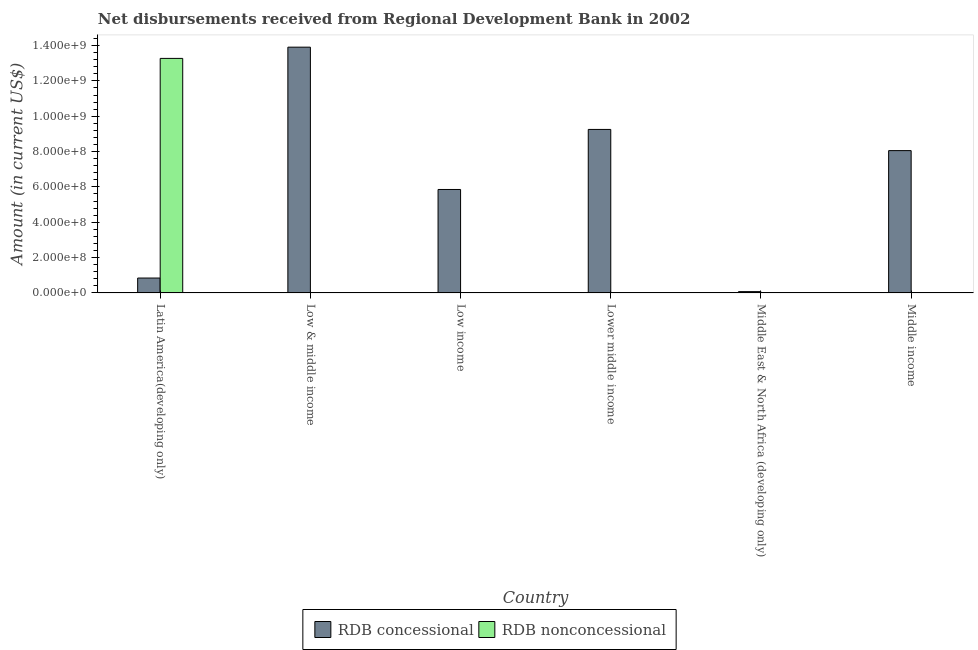Are the number of bars per tick equal to the number of legend labels?
Your response must be concise. No. Are the number of bars on each tick of the X-axis equal?
Offer a terse response. No. How many bars are there on the 5th tick from the left?
Give a very brief answer. 1. How many bars are there on the 3rd tick from the right?
Provide a succinct answer. 1. What is the label of the 3rd group of bars from the left?
Your answer should be compact. Low income. In how many cases, is the number of bars for a given country not equal to the number of legend labels?
Give a very brief answer. 5. What is the net non concessional disbursements from rdb in Latin America(developing only)?
Provide a succinct answer. 1.33e+09. Across all countries, what is the maximum net non concessional disbursements from rdb?
Make the answer very short. 1.33e+09. Across all countries, what is the minimum net concessional disbursements from rdb?
Your answer should be compact. 7.38e+06. In which country was the net non concessional disbursements from rdb maximum?
Provide a short and direct response. Latin America(developing only). What is the total net concessional disbursements from rdb in the graph?
Offer a terse response. 3.80e+09. What is the difference between the net concessional disbursements from rdb in Latin America(developing only) and that in Middle East & North Africa (developing only)?
Ensure brevity in your answer.  7.69e+07. What is the difference between the net concessional disbursements from rdb in Middle income and the net non concessional disbursements from rdb in Low & middle income?
Provide a short and direct response. 8.05e+08. What is the average net concessional disbursements from rdb per country?
Provide a succinct answer. 6.33e+08. What is the difference between the net non concessional disbursements from rdb and net concessional disbursements from rdb in Latin America(developing only)?
Your answer should be compact. 1.24e+09. In how many countries, is the net non concessional disbursements from rdb greater than 440000000 US$?
Provide a succinct answer. 1. What is the ratio of the net concessional disbursements from rdb in Latin America(developing only) to that in Low & middle income?
Give a very brief answer. 0.06. What is the difference between the highest and the second highest net concessional disbursements from rdb?
Ensure brevity in your answer.  4.66e+08. What is the difference between the highest and the lowest net non concessional disbursements from rdb?
Offer a very short reply. 1.33e+09. How many bars are there?
Your answer should be very brief. 7. Are all the bars in the graph horizontal?
Provide a succinct answer. No. What is the difference between two consecutive major ticks on the Y-axis?
Keep it short and to the point. 2.00e+08. Are the values on the major ticks of Y-axis written in scientific E-notation?
Your answer should be compact. Yes. Does the graph contain grids?
Keep it short and to the point. No. How many legend labels are there?
Ensure brevity in your answer.  2. How are the legend labels stacked?
Offer a terse response. Horizontal. What is the title of the graph?
Keep it short and to the point. Net disbursements received from Regional Development Bank in 2002. Does "Goods" appear as one of the legend labels in the graph?
Keep it short and to the point. No. What is the Amount (in current US$) of RDB concessional in Latin America(developing only)?
Provide a succinct answer. 8.43e+07. What is the Amount (in current US$) in RDB nonconcessional in Latin America(developing only)?
Your answer should be compact. 1.33e+09. What is the Amount (in current US$) in RDB concessional in Low & middle income?
Make the answer very short. 1.39e+09. What is the Amount (in current US$) in RDB concessional in Low income?
Your answer should be very brief. 5.86e+08. What is the Amount (in current US$) of RDB concessional in Lower middle income?
Ensure brevity in your answer.  9.25e+08. What is the Amount (in current US$) of RDB concessional in Middle East & North Africa (developing only)?
Offer a very short reply. 7.38e+06. What is the Amount (in current US$) in RDB concessional in Middle income?
Your answer should be compact. 8.05e+08. Across all countries, what is the maximum Amount (in current US$) of RDB concessional?
Your answer should be compact. 1.39e+09. Across all countries, what is the maximum Amount (in current US$) of RDB nonconcessional?
Ensure brevity in your answer.  1.33e+09. Across all countries, what is the minimum Amount (in current US$) in RDB concessional?
Give a very brief answer. 7.38e+06. What is the total Amount (in current US$) of RDB concessional in the graph?
Your answer should be very brief. 3.80e+09. What is the total Amount (in current US$) of RDB nonconcessional in the graph?
Provide a succinct answer. 1.33e+09. What is the difference between the Amount (in current US$) in RDB concessional in Latin America(developing only) and that in Low & middle income?
Your response must be concise. -1.31e+09. What is the difference between the Amount (in current US$) in RDB concessional in Latin America(developing only) and that in Low income?
Ensure brevity in your answer.  -5.01e+08. What is the difference between the Amount (in current US$) of RDB concessional in Latin America(developing only) and that in Lower middle income?
Your answer should be compact. -8.41e+08. What is the difference between the Amount (in current US$) of RDB concessional in Latin America(developing only) and that in Middle East & North Africa (developing only)?
Your answer should be very brief. 7.69e+07. What is the difference between the Amount (in current US$) of RDB concessional in Latin America(developing only) and that in Middle income?
Your answer should be compact. -7.21e+08. What is the difference between the Amount (in current US$) of RDB concessional in Low & middle income and that in Low income?
Your response must be concise. 8.05e+08. What is the difference between the Amount (in current US$) in RDB concessional in Low & middle income and that in Lower middle income?
Offer a terse response. 4.66e+08. What is the difference between the Amount (in current US$) in RDB concessional in Low & middle income and that in Middle East & North Africa (developing only)?
Provide a short and direct response. 1.38e+09. What is the difference between the Amount (in current US$) of RDB concessional in Low & middle income and that in Middle income?
Make the answer very short. 5.86e+08. What is the difference between the Amount (in current US$) of RDB concessional in Low income and that in Lower middle income?
Ensure brevity in your answer.  -3.40e+08. What is the difference between the Amount (in current US$) in RDB concessional in Low income and that in Middle East & North Africa (developing only)?
Make the answer very short. 5.78e+08. What is the difference between the Amount (in current US$) of RDB concessional in Low income and that in Middle income?
Ensure brevity in your answer.  -2.20e+08. What is the difference between the Amount (in current US$) in RDB concessional in Lower middle income and that in Middle East & North Africa (developing only)?
Your answer should be compact. 9.18e+08. What is the difference between the Amount (in current US$) of RDB concessional in Lower middle income and that in Middle income?
Your response must be concise. 1.20e+08. What is the difference between the Amount (in current US$) in RDB concessional in Middle East & North Africa (developing only) and that in Middle income?
Provide a short and direct response. -7.98e+08. What is the average Amount (in current US$) in RDB concessional per country?
Your response must be concise. 6.33e+08. What is the average Amount (in current US$) of RDB nonconcessional per country?
Your answer should be compact. 2.21e+08. What is the difference between the Amount (in current US$) in RDB concessional and Amount (in current US$) in RDB nonconcessional in Latin America(developing only)?
Your answer should be very brief. -1.24e+09. What is the ratio of the Amount (in current US$) in RDB concessional in Latin America(developing only) to that in Low & middle income?
Provide a succinct answer. 0.06. What is the ratio of the Amount (in current US$) in RDB concessional in Latin America(developing only) to that in Low income?
Provide a succinct answer. 0.14. What is the ratio of the Amount (in current US$) in RDB concessional in Latin America(developing only) to that in Lower middle income?
Your response must be concise. 0.09. What is the ratio of the Amount (in current US$) in RDB concessional in Latin America(developing only) to that in Middle East & North Africa (developing only)?
Your answer should be compact. 11.43. What is the ratio of the Amount (in current US$) in RDB concessional in Latin America(developing only) to that in Middle income?
Your answer should be compact. 0.1. What is the ratio of the Amount (in current US$) of RDB concessional in Low & middle income to that in Low income?
Your response must be concise. 2.38. What is the ratio of the Amount (in current US$) in RDB concessional in Low & middle income to that in Lower middle income?
Ensure brevity in your answer.  1.5. What is the ratio of the Amount (in current US$) of RDB concessional in Low & middle income to that in Middle East & North Africa (developing only)?
Keep it short and to the point. 188.52. What is the ratio of the Amount (in current US$) of RDB concessional in Low & middle income to that in Middle income?
Provide a short and direct response. 1.73. What is the ratio of the Amount (in current US$) of RDB concessional in Low income to that in Lower middle income?
Your answer should be compact. 0.63. What is the ratio of the Amount (in current US$) in RDB concessional in Low income to that in Middle East & North Africa (developing only)?
Your response must be concise. 79.36. What is the ratio of the Amount (in current US$) of RDB concessional in Low income to that in Middle income?
Provide a short and direct response. 0.73. What is the ratio of the Amount (in current US$) of RDB concessional in Lower middle income to that in Middle East & North Africa (developing only)?
Your answer should be compact. 125.42. What is the ratio of the Amount (in current US$) in RDB concessional in Lower middle income to that in Middle income?
Your response must be concise. 1.15. What is the ratio of the Amount (in current US$) in RDB concessional in Middle East & North Africa (developing only) to that in Middle income?
Provide a succinct answer. 0.01. What is the difference between the highest and the second highest Amount (in current US$) in RDB concessional?
Ensure brevity in your answer.  4.66e+08. What is the difference between the highest and the lowest Amount (in current US$) of RDB concessional?
Your response must be concise. 1.38e+09. What is the difference between the highest and the lowest Amount (in current US$) of RDB nonconcessional?
Your response must be concise. 1.33e+09. 